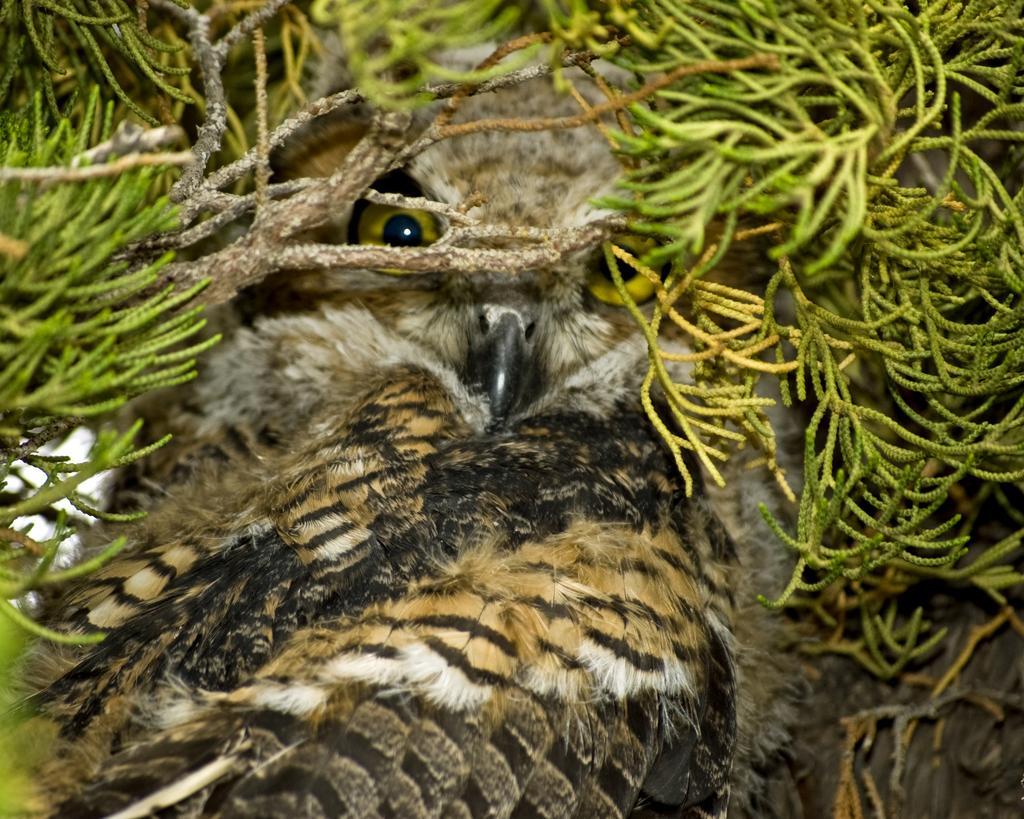Please provide a concise description of this image. In this image I can see there is an owl in between the leaves of a tree and it has brown feathers. 